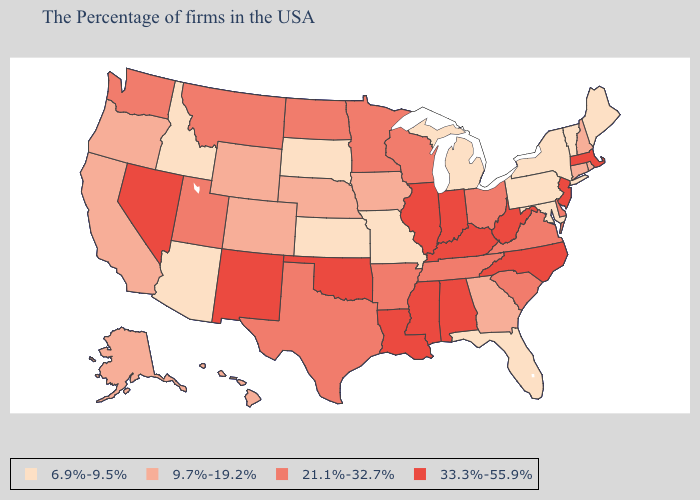Name the states that have a value in the range 9.7%-19.2%?
Concise answer only. Rhode Island, New Hampshire, Connecticut, Georgia, Iowa, Nebraska, Wyoming, Colorado, California, Oregon, Alaska, Hawaii. Name the states that have a value in the range 21.1%-32.7%?
Be succinct. Delaware, Virginia, South Carolina, Ohio, Tennessee, Wisconsin, Arkansas, Minnesota, Texas, North Dakota, Utah, Montana, Washington. What is the value of Connecticut?
Give a very brief answer. 9.7%-19.2%. Name the states that have a value in the range 33.3%-55.9%?
Write a very short answer. Massachusetts, New Jersey, North Carolina, West Virginia, Kentucky, Indiana, Alabama, Illinois, Mississippi, Louisiana, Oklahoma, New Mexico, Nevada. How many symbols are there in the legend?
Short answer required. 4. What is the highest value in states that border Florida?
Give a very brief answer. 33.3%-55.9%. Name the states that have a value in the range 33.3%-55.9%?
Be succinct. Massachusetts, New Jersey, North Carolina, West Virginia, Kentucky, Indiana, Alabama, Illinois, Mississippi, Louisiana, Oklahoma, New Mexico, Nevada. Does Rhode Island have a higher value than Pennsylvania?
Short answer required. Yes. What is the highest value in states that border Michigan?
Keep it brief. 33.3%-55.9%. Among the states that border Michigan , which have the highest value?
Be succinct. Indiana. Does Indiana have the lowest value in the MidWest?
Be succinct. No. Does the first symbol in the legend represent the smallest category?
Be succinct. Yes. What is the highest value in the Northeast ?
Write a very short answer. 33.3%-55.9%. Does Oklahoma have a higher value than Washington?
Keep it brief. Yes. What is the value of California?
Write a very short answer. 9.7%-19.2%. 